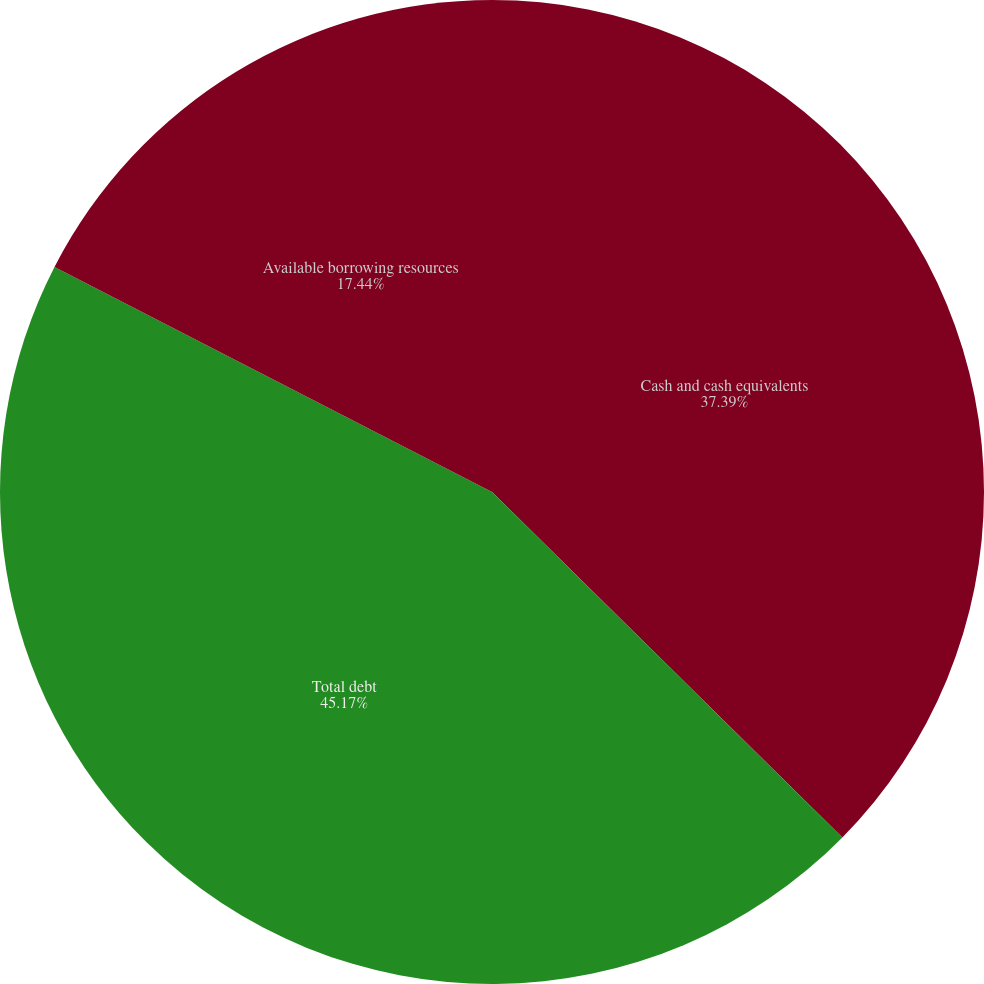Convert chart. <chart><loc_0><loc_0><loc_500><loc_500><pie_chart><fcel>Cash and cash equivalents<fcel>Total debt<fcel>Available borrowing resources<nl><fcel>37.39%<fcel>45.18%<fcel>17.44%<nl></chart> 